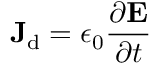Convert formula to latex. <formula><loc_0><loc_0><loc_500><loc_500>J _ { d } = \epsilon _ { 0 } { \frac { \partial E } { \partial t } } \,</formula> 